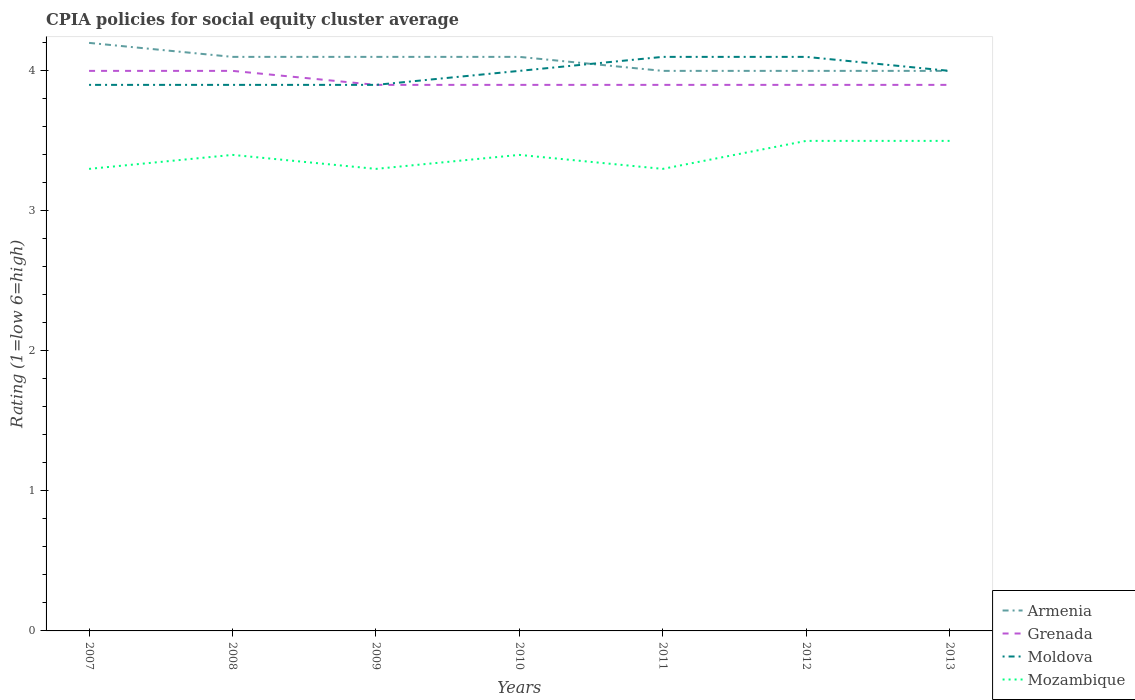How many different coloured lines are there?
Offer a very short reply. 4. Across all years, what is the maximum CPIA rating in Moldova?
Offer a very short reply. 3.9. In which year was the CPIA rating in Armenia maximum?
Offer a very short reply. 2011. What is the difference between the highest and the second highest CPIA rating in Mozambique?
Your response must be concise. 0.2. Is the CPIA rating in Mozambique strictly greater than the CPIA rating in Grenada over the years?
Your response must be concise. Yes. What is the title of the graph?
Your response must be concise. CPIA policies for social equity cluster average. What is the label or title of the X-axis?
Your response must be concise. Years. What is the label or title of the Y-axis?
Offer a terse response. Rating (1=low 6=high). What is the Rating (1=low 6=high) in Grenada in 2007?
Your answer should be compact. 4. What is the Rating (1=low 6=high) of Armenia in 2008?
Your answer should be compact. 4.1. What is the Rating (1=low 6=high) in Grenada in 2008?
Offer a terse response. 4. What is the Rating (1=low 6=high) in Mozambique in 2008?
Ensure brevity in your answer.  3.4. What is the Rating (1=low 6=high) in Armenia in 2009?
Make the answer very short. 4.1. What is the Rating (1=low 6=high) of Moldova in 2009?
Your answer should be very brief. 3.9. What is the Rating (1=low 6=high) in Mozambique in 2009?
Your response must be concise. 3.3. What is the Rating (1=low 6=high) of Armenia in 2010?
Ensure brevity in your answer.  4.1. What is the Rating (1=low 6=high) of Mozambique in 2010?
Offer a terse response. 3.4. What is the Rating (1=low 6=high) of Moldova in 2011?
Your answer should be compact. 4.1. What is the Rating (1=low 6=high) in Mozambique in 2011?
Your answer should be very brief. 3.3. What is the Rating (1=low 6=high) in Armenia in 2012?
Your response must be concise. 4. What is the Rating (1=low 6=high) of Mozambique in 2012?
Provide a succinct answer. 3.5. What is the Rating (1=low 6=high) of Armenia in 2013?
Make the answer very short. 4. What is the Rating (1=low 6=high) in Mozambique in 2013?
Offer a very short reply. 3.5. Across all years, what is the maximum Rating (1=low 6=high) of Grenada?
Provide a succinct answer. 4. Across all years, what is the maximum Rating (1=low 6=high) in Moldova?
Your answer should be very brief. 4.1. Across all years, what is the maximum Rating (1=low 6=high) of Mozambique?
Give a very brief answer. 3.5. Across all years, what is the minimum Rating (1=low 6=high) in Moldova?
Your answer should be compact. 3.9. What is the total Rating (1=low 6=high) of Armenia in the graph?
Your response must be concise. 28.5. What is the total Rating (1=low 6=high) of Grenada in the graph?
Offer a very short reply. 27.5. What is the total Rating (1=low 6=high) in Moldova in the graph?
Keep it short and to the point. 27.9. What is the total Rating (1=low 6=high) of Mozambique in the graph?
Your response must be concise. 23.7. What is the difference between the Rating (1=low 6=high) in Armenia in 2007 and that in 2008?
Your response must be concise. 0.1. What is the difference between the Rating (1=low 6=high) of Grenada in 2007 and that in 2008?
Ensure brevity in your answer.  0. What is the difference between the Rating (1=low 6=high) of Grenada in 2007 and that in 2009?
Keep it short and to the point. 0.1. What is the difference between the Rating (1=low 6=high) of Moldova in 2007 and that in 2009?
Provide a succinct answer. 0. What is the difference between the Rating (1=low 6=high) in Mozambique in 2007 and that in 2009?
Offer a very short reply. 0. What is the difference between the Rating (1=low 6=high) in Moldova in 2007 and that in 2010?
Your response must be concise. -0.1. What is the difference between the Rating (1=low 6=high) in Armenia in 2007 and that in 2011?
Give a very brief answer. 0.2. What is the difference between the Rating (1=low 6=high) in Moldova in 2007 and that in 2011?
Your response must be concise. -0.2. What is the difference between the Rating (1=low 6=high) in Mozambique in 2007 and that in 2011?
Offer a terse response. 0. What is the difference between the Rating (1=low 6=high) in Moldova in 2007 and that in 2012?
Give a very brief answer. -0.2. What is the difference between the Rating (1=low 6=high) of Mozambique in 2007 and that in 2012?
Provide a short and direct response. -0.2. What is the difference between the Rating (1=low 6=high) in Grenada in 2007 and that in 2013?
Ensure brevity in your answer.  0.1. What is the difference between the Rating (1=low 6=high) in Mozambique in 2007 and that in 2013?
Provide a succinct answer. -0.2. What is the difference between the Rating (1=low 6=high) of Mozambique in 2008 and that in 2009?
Your answer should be very brief. 0.1. What is the difference between the Rating (1=low 6=high) in Armenia in 2008 and that in 2010?
Offer a terse response. 0. What is the difference between the Rating (1=low 6=high) of Moldova in 2008 and that in 2010?
Your response must be concise. -0.1. What is the difference between the Rating (1=low 6=high) in Mozambique in 2008 and that in 2011?
Give a very brief answer. 0.1. What is the difference between the Rating (1=low 6=high) of Armenia in 2008 and that in 2012?
Make the answer very short. 0.1. What is the difference between the Rating (1=low 6=high) in Moldova in 2008 and that in 2012?
Your answer should be very brief. -0.2. What is the difference between the Rating (1=low 6=high) of Mozambique in 2008 and that in 2012?
Offer a very short reply. -0.1. What is the difference between the Rating (1=low 6=high) of Armenia in 2008 and that in 2013?
Make the answer very short. 0.1. What is the difference between the Rating (1=low 6=high) of Grenada in 2008 and that in 2013?
Provide a succinct answer. 0.1. What is the difference between the Rating (1=low 6=high) in Mozambique in 2008 and that in 2013?
Provide a succinct answer. -0.1. What is the difference between the Rating (1=low 6=high) in Mozambique in 2009 and that in 2010?
Provide a succinct answer. -0.1. What is the difference between the Rating (1=low 6=high) of Armenia in 2009 and that in 2011?
Offer a terse response. 0.1. What is the difference between the Rating (1=low 6=high) of Grenada in 2009 and that in 2011?
Give a very brief answer. 0. What is the difference between the Rating (1=low 6=high) of Moldova in 2009 and that in 2011?
Your response must be concise. -0.2. What is the difference between the Rating (1=low 6=high) in Armenia in 2009 and that in 2013?
Ensure brevity in your answer.  0.1. What is the difference between the Rating (1=low 6=high) of Grenada in 2009 and that in 2013?
Provide a short and direct response. 0. What is the difference between the Rating (1=low 6=high) in Moldova in 2009 and that in 2013?
Your answer should be compact. -0.1. What is the difference between the Rating (1=low 6=high) in Armenia in 2010 and that in 2011?
Keep it short and to the point. 0.1. What is the difference between the Rating (1=low 6=high) of Grenada in 2010 and that in 2011?
Keep it short and to the point. 0. What is the difference between the Rating (1=low 6=high) in Moldova in 2010 and that in 2011?
Give a very brief answer. -0.1. What is the difference between the Rating (1=low 6=high) of Mozambique in 2010 and that in 2011?
Give a very brief answer. 0.1. What is the difference between the Rating (1=low 6=high) in Armenia in 2010 and that in 2012?
Provide a short and direct response. 0.1. What is the difference between the Rating (1=low 6=high) of Grenada in 2010 and that in 2012?
Your answer should be compact. 0. What is the difference between the Rating (1=low 6=high) of Moldova in 2010 and that in 2012?
Provide a short and direct response. -0.1. What is the difference between the Rating (1=low 6=high) of Armenia in 2010 and that in 2013?
Provide a short and direct response. 0.1. What is the difference between the Rating (1=low 6=high) of Moldova in 2010 and that in 2013?
Offer a very short reply. 0. What is the difference between the Rating (1=low 6=high) in Mozambique in 2010 and that in 2013?
Your response must be concise. -0.1. What is the difference between the Rating (1=low 6=high) of Mozambique in 2011 and that in 2012?
Offer a very short reply. -0.2. What is the difference between the Rating (1=low 6=high) in Mozambique in 2011 and that in 2013?
Keep it short and to the point. -0.2. What is the difference between the Rating (1=low 6=high) in Armenia in 2012 and that in 2013?
Make the answer very short. 0. What is the difference between the Rating (1=low 6=high) in Grenada in 2012 and that in 2013?
Keep it short and to the point. 0. What is the difference between the Rating (1=low 6=high) of Mozambique in 2012 and that in 2013?
Give a very brief answer. 0. What is the difference between the Rating (1=low 6=high) of Armenia in 2007 and the Rating (1=low 6=high) of Grenada in 2008?
Provide a succinct answer. 0.2. What is the difference between the Rating (1=low 6=high) of Grenada in 2007 and the Rating (1=low 6=high) of Moldova in 2008?
Make the answer very short. 0.1. What is the difference between the Rating (1=low 6=high) of Grenada in 2007 and the Rating (1=low 6=high) of Mozambique in 2008?
Your answer should be very brief. 0.6. What is the difference between the Rating (1=low 6=high) of Armenia in 2007 and the Rating (1=low 6=high) of Grenada in 2009?
Provide a short and direct response. 0.3. What is the difference between the Rating (1=low 6=high) in Armenia in 2007 and the Rating (1=low 6=high) in Mozambique in 2009?
Provide a succinct answer. 0.9. What is the difference between the Rating (1=low 6=high) in Moldova in 2007 and the Rating (1=low 6=high) in Mozambique in 2009?
Your answer should be very brief. 0.6. What is the difference between the Rating (1=low 6=high) in Armenia in 2007 and the Rating (1=low 6=high) in Grenada in 2010?
Keep it short and to the point. 0.3. What is the difference between the Rating (1=low 6=high) of Grenada in 2007 and the Rating (1=low 6=high) of Moldova in 2010?
Offer a terse response. 0. What is the difference between the Rating (1=low 6=high) in Moldova in 2007 and the Rating (1=low 6=high) in Mozambique in 2010?
Offer a terse response. 0.5. What is the difference between the Rating (1=low 6=high) in Armenia in 2007 and the Rating (1=low 6=high) in Grenada in 2011?
Provide a short and direct response. 0.3. What is the difference between the Rating (1=low 6=high) of Armenia in 2007 and the Rating (1=low 6=high) of Moldova in 2011?
Make the answer very short. 0.1. What is the difference between the Rating (1=low 6=high) in Armenia in 2007 and the Rating (1=low 6=high) in Mozambique in 2011?
Keep it short and to the point. 0.9. What is the difference between the Rating (1=low 6=high) in Armenia in 2007 and the Rating (1=low 6=high) in Grenada in 2012?
Provide a short and direct response. 0.3. What is the difference between the Rating (1=low 6=high) in Armenia in 2007 and the Rating (1=low 6=high) in Mozambique in 2012?
Your answer should be compact. 0.7. What is the difference between the Rating (1=low 6=high) of Grenada in 2007 and the Rating (1=low 6=high) of Mozambique in 2012?
Your response must be concise. 0.5. What is the difference between the Rating (1=low 6=high) in Armenia in 2007 and the Rating (1=low 6=high) in Moldova in 2013?
Offer a very short reply. 0.2. What is the difference between the Rating (1=low 6=high) in Moldova in 2007 and the Rating (1=low 6=high) in Mozambique in 2013?
Keep it short and to the point. 0.4. What is the difference between the Rating (1=low 6=high) in Grenada in 2008 and the Rating (1=low 6=high) in Moldova in 2009?
Provide a short and direct response. 0.1. What is the difference between the Rating (1=low 6=high) of Armenia in 2008 and the Rating (1=low 6=high) of Grenada in 2010?
Your answer should be very brief. 0.2. What is the difference between the Rating (1=low 6=high) of Armenia in 2008 and the Rating (1=low 6=high) of Moldova in 2010?
Provide a short and direct response. 0.1. What is the difference between the Rating (1=low 6=high) of Armenia in 2008 and the Rating (1=low 6=high) of Mozambique in 2010?
Offer a very short reply. 0.7. What is the difference between the Rating (1=low 6=high) of Grenada in 2008 and the Rating (1=low 6=high) of Moldova in 2010?
Make the answer very short. 0. What is the difference between the Rating (1=low 6=high) of Armenia in 2008 and the Rating (1=low 6=high) of Moldova in 2011?
Provide a short and direct response. 0. What is the difference between the Rating (1=low 6=high) in Armenia in 2008 and the Rating (1=low 6=high) in Mozambique in 2011?
Your answer should be very brief. 0.8. What is the difference between the Rating (1=low 6=high) of Grenada in 2008 and the Rating (1=low 6=high) of Moldova in 2011?
Your answer should be very brief. -0.1. What is the difference between the Rating (1=low 6=high) in Grenada in 2008 and the Rating (1=low 6=high) in Mozambique in 2011?
Your answer should be compact. 0.7. What is the difference between the Rating (1=low 6=high) of Moldova in 2008 and the Rating (1=low 6=high) of Mozambique in 2011?
Your answer should be very brief. 0.6. What is the difference between the Rating (1=low 6=high) of Armenia in 2008 and the Rating (1=low 6=high) of Mozambique in 2012?
Give a very brief answer. 0.6. What is the difference between the Rating (1=low 6=high) in Grenada in 2008 and the Rating (1=low 6=high) in Mozambique in 2012?
Your answer should be compact. 0.5. What is the difference between the Rating (1=low 6=high) of Moldova in 2008 and the Rating (1=low 6=high) of Mozambique in 2012?
Your answer should be very brief. 0.4. What is the difference between the Rating (1=low 6=high) in Armenia in 2008 and the Rating (1=low 6=high) in Grenada in 2013?
Give a very brief answer. 0.2. What is the difference between the Rating (1=low 6=high) in Armenia in 2008 and the Rating (1=low 6=high) in Moldova in 2013?
Your answer should be very brief. 0.1. What is the difference between the Rating (1=low 6=high) of Armenia in 2008 and the Rating (1=low 6=high) of Mozambique in 2013?
Give a very brief answer. 0.6. What is the difference between the Rating (1=low 6=high) of Grenada in 2008 and the Rating (1=low 6=high) of Moldova in 2013?
Your answer should be compact. 0. What is the difference between the Rating (1=low 6=high) in Moldova in 2008 and the Rating (1=low 6=high) in Mozambique in 2013?
Offer a very short reply. 0.4. What is the difference between the Rating (1=low 6=high) of Armenia in 2009 and the Rating (1=low 6=high) of Grenada in 2010?
Provide a short and direct response. 0.2. What is the difference between the Rating (1=low 6=high) in Armenia in 2009 and the Rating (1=low 6=high) in Moldova in 2010?
Give a very brief answer. 0.1. What is the difference between the Rating (1=low 6=high) of Grenada in 2009 and the Rating (1=low 6=high) of Moldova in 2010?
Offer a very short reply. -0.1. What is the difference between the Rating (1=low 6=high) in Grenada in 2009 and the Rating (1=low 6=high) in Mozambique in 2010?
Provide a succinct answer. 0.5. What is the difference between the Rating (1=low 6=high) of Armenia in 2009 and the Rating (1=low 6=high) of Grenada in 2011?
Give a very brief answer. 0.2. What is the difference between the Rating (1=low 6=high) in Armenia in 2009 and the Rating (1=low 6=high) in Moldova in 2011?
Ensure brevity in your answer.  0. What is the difference between the Rating (1=low 6=high) of Grenada in 2009 and the Rating (1=low 6=high) of Moldova in 2011?
Provide a short and direct response. -0.2. What is the difference between the Rating (1=low 6=high) in Grenada in 2009 and the Rating (1=low 6=high) in Mozambique in 2011?
Make the answer very short. 0.6. What is the difference between the Rating (1=low 6=high) in Moldova in 2009 and the Rating (1=low 6=high) in Mozambique in 2011?
Make the answer very short. 0.6. What is the difference between the Rating (1=low 6=high) of Armenia in 2009 and the Rating (1=low 6=high) of Grenada in 2012?
Your answer should be compact. 0.2. What is the difference between the Rating (1=low 6=high) in Armenia in 2009 and the Rating (1=low 6=high) in Moldova in 2012?
Keep it short and to the point. 0. What is the difference between the Rating (1=low 6=high) of Grenada in 2009 and the Rating (1=low 6=high) of Moldova in 2012?
Your answer should be very brief. -0.2. What is the difference between the Rating (1=low 6=high) in Armenia in 2009 and the Rating (1=low 6=high) in Grenada in 2013?
Offer a very short reply. 0.2. What is the difference between the Rating (1=low 6=high) of Grenada in 2009 and the Rating (1=low 6=high) of Moldova in 2013?
Provide a succinct answer. -0.1. What is the difference between the Rating (1=low 6=high) in Armenia in 2010 and the Rating (1=low 6=high) in Moldova in 2011?
Offer a very short reply. 0. What is the difference between the Rating (1=low 6=high) in Armenia in 2010 and the Rating (1=low 6=high) in Mozambique in 2011?
Offer a very short reply. 0.8. What is the difference between the Rating (1=low 6=high) of Moldova in 2010 and the Rating (1=low 6=high) of Mozambique in 2011?
Ensure brevity in your answer.  0.7. What is the difference between the Rating (1=low 6=high) in Armenia in 2010 and the Rating (1=low 6=high) in Grenada in 2012?
Ensure brevity in your answer.  0.2. What is the difference between the Rating (1=low 6=high) of Armenia in 2010 and the Rating (1=low 6=high) of Moldova in 2012?
Keep it short and to the point. 0. What is the difference between the Rating (1=low 6=high) in Armenia in 2010 and the Rating (1=low 6=high) in Mozambique in 2012?
Give a very brief answer. 0.6. What is the difference between the Rating (1=low 6=high) in Grenada in 2010 and the Rating (1=low 6=high) in Mozambique in 2012?
Your response must be concise. 0.4. What is the difference between the Rating (1=low 6=high) of Moldova in 2010 and the Rating (1=low 6=high) of Mozambique in 2012?
Offer a very short reply. 0.5. What is the difference between the Rating (1=low 6=high) in Armenia in 2010 and the Rating (1=low 6=high) in Grenada in 2013?
Offer a very short reply. 0.2. What is the difference between the Rating (1=low 6=high) of Armenia in 2010 and the Rating (1=low 6=high) of Moldova in 2013?
Ensure brevity in your answer.  0.1. What is the difference between the Rating (1=low 6=high) in Grenada in 2010 and the Rating (1=low 6=high) in Moldova in 2013?
Provide a short and direct response. -0.1. What is the difference between the Rating (1=low 6=high) in Grenada in 2011 and the Rating (1=low 6=high) in Moldova in 2012?
Offer a terse response. -0.2. What is the difference between the Rating (1=low 6=high) of Grenada in 2011 and the Rating (1=low 6=high) of Mozambique in 2012?
Provide a succinct answer. 0.4. What is the difference between the Rating (1=low 6=high) of Armenia in 2011 and the Rating (1=low 6=high) of Moldova in 2013?
Provide a succinct answer. 0. What is the difference between the Rating (1=low 6=high) of Grenada in 2011 and the Rating (1=low 6=high) of Moldova in 2013?
Your response must be concise. -0.1. What is the difference between the Rating (1=low 6=high) in Armenia in 2012 and the Rating (1=low 6=high) in Grenada in 2013?
Keep it short and to the point. 0.1. What is the difference between the Rating (1=low 6=high) in Armenia in 2012 and the Rating (1=low 6=high) in Mozambique in 2013?
Offer a very short reply. 0.5. What is the difference between the Rating (1=low 6=high) in Grenada in 2012 and the Rating (1=low 6=high) in Moldova in 2013?
Offer a very short reply. -0.1. What is the difference between the Rating (1=low 6=high) in Grenada in 2012 and the Rating (1=low 6=high) in Mozambique in 2013?
Make the answer very short. 0.4. What is the difference between the Rating (1=low 6=high) in Moldova in 2012 and the Rating (1=low 6=high) in Mozambique in 2013?
Keep it short and to the point. 0.6. What is the average Rating (1=low 6=high) of Armenia per year?
Offer a terse response. 4.07. What is the average Rating (1=low 6=high) in Grenada per year?
Give a very brief answer. 3.93. What is the average Rating (1=low 6=high) in Moldova per year?
Your answer should be compact. 3.99. What is the average Rating (1=low 6=high) in Mozambique per year?
Offer a terse response. 3.39. In the year 2007, what is the difference between the Rating (1=low 6=high) in Armenia and Rating (1=low 6=high) in Moldova?
Your response must be concise. 0.3. In the year 2007, what is the difference between the Rating (1=low 6=high) of Armenia and Rating (1=low 6=high) of Mozambique?
Your answer should be compact. 0.9. In the year 2007, what is the difference between the Rating (1=low 6=high) of Grenada and Rating (1=low 6=high) of Moldova?
Offer a very short reply. 0.1. In the year 2007, what is the difference between the Rating (1=low 6=high) in Moldova and Rating (1=low 6=high) in Mozambique?
Make the answer very short. 0.6. In the year 2008, what is the difference between the Rating (1=low 6=high) of Armenia and Rating (1=low 6=high) of Moldova?
Your response must be concise. 0.2. In the year 2008, what is the difference between the Rating (1=low 6=high) of Armenia and Rating (1=low 6=high) of Mozambique?
Give a very brief answer. 0.7. In the year 2008, what is the difference between the Rating (1=low 6=high) in Grenada and Rating (1=low 6=high) in Moldova?
Provide a succinct answer. 0.1. In the year 2008, what is the difference between the Rating (1=low 6=high) of Grenada and Rating (1=low 6=high) of Mozambique?
Give a very brief answer. 0.6. In the year 2008, what is the difference between the Rating (1=low 6=high) of Moldova and Rating (1=low 6=high) of Mozambique?
Provide a short and direct response. 0.5. In the year 2010, what is the difference between the Rating (1=low 6=high) of Armenia and Rating (1=low 6=high) of Moldova?
Make the answer very short. 0.1. In the year 2010, what is the difference between the Rating (1=low 6=high) of Armenia and Rating (1=low 6=high) of Mozambique?
Offer a terse response. 0.7. In the year 2010, what is the difference between the Rating (1=low 6=high) of Grenada and Rating (1=low 6=high) of Moldova?
Your answer should be compact. -0.1. In the year 2011, what is the difference between the Rating (1=low 6=high) in Armenia and Rating (1=low 6=high) in Grenada?
Provide a short and direct response. 0.1. In the year 2011, what is the difference between the Rating (1=low 6=high) of Armenia and Rating (1=low 6=high) of Moldova?
Provide a succinct answer. -0.1. In the year 2011, what is the difference between the Rating (1=low 6=high) in Moldova and Rating (1=low 6=high) in Mozambique?
Give a very brief answer. 0.8. In the year 2012, what is the difference between the Rating (1=low 6=high) of Armenia and Rating (1=low 6=high) of Grenada?
Keep it short and to the point. 0.1. In the year 2012, what is the difference between the Rating (1=low 6=high) in Armenia and Rating (1=low 6=high) in Moldova?
Give a very brief answer. -0.1. In the year 2013, what is the difference between the Rating (1=low 6=high) of Armenia and Rating (1=low 6=high) of Moldova?
Ensure brevity in your answer.  0. In the year 2013, what is the difference between the Rating (1=low 6=high) of Grenada and Rating (1=low 6=high) of Moldova?
Your response must be concise. -0.1. What is the ratio of the Rating (1=low 6=high) in Armenia in 2007 to that in 2008?
Make the answer very short. 1.02. What is the ratio of the Rating (1=low 6=high) of Moldova in 2007 to that in 2008?
Give a very brief answer. 1. What is the ratio of the Rating (1=low 6=high) in Mozambique in 2007 to that in 2008?
Provide a short and direct response. 0.97. What is the ratio of the Rating (1=low 6=high) in Armenia in 2007 to that in 2009?
Make the answer very short. 1.02. What is the ratio of the Rating (1=low 6=high) in Grenada in 2007 to that in 2009?
Ensure brevity in your answer.  1.03. What is the ratio of the Rating (1=low 6=high) in Armenia in 2007 to that in 2010?
Make the answer very short. 1.02. What is the ratio of the Rating (1=low 6=high) in Grenada in 2007 to that in 2010?
Ensure brevity in your answer.  1.03. What is the ratio of the Rating (1=low 6=high) of Mozambique in 2007 to that in 2010?
Offer a terse response. 0.97. What is the ratio of the Rating (1=low 6=high) in Armenia in 2007 to that in 2011?
Provide a short and direct response. 1.05. What is the ratio of the Rating (1=low 6=high) of Grenada in 2007 to that in 2011?
Your response must be concise. 1.03. What is the ratio of the Rating (1=low 6=high) in Moldova in 2007 to that in 2011?
Provide a short and direct response. 0.95. What is the ratio of the Rating (1=low 6=high) of Grenada in 2007 to that in 2012?
Keep it short and to the point. 1.03. What is the ratio of the Rating (1=low 6=high) of Moldova in 2007 to that in 2012?
Ensure brevity in your answer.  0.95. What is the ratio of the Rating (1=low 6=high) in Mozambique in 2007 to that in 2012?
Ensure brevity in your answer.  0.94. What is the ratio of the Rating (1=low 6=high) in Grenada in 2007 to that in 2013?
Your answer should be compact. 1.03. What is the ratio of the Rating (1=low 6=high) in Mozambique in 2007 to that in 2013?
Offer a very short reply. 0.94. What is the ratio of the Rating (1=low 6=high) of Armenia in 2008 to that in 2009?
Your answer should be very brief. 1. What is the ratio of the Rating (1=low 6=high) in Grenada in 2008 to that in 2009?
Keep it short and to the point. 1.03. What is the ratio of the Rating (1=low 6=high) of Mozambique in 2008 to that in 2009?
Ensure brevity in your answer.  1.03. What is the ratio of the Rating (1=low 6=high) of Armenia in 2008 to that in 2010?
Ensure brevity in your answer.  1. What is the ratio of the Rating (1=low 6=high) of Grenada in 2008 to that in 2010?
Offer a terse response. 1.03. What is the ratio of the Rating (1=low 6=high) of Moldova in 2008 to that in 2010?
Your answer should be compact. 0.97. What is the ratio of the Rating (1=low 6=high) of Grenada in 2008 to that in 2011?
Make the answer very short. 1.03. What is the ratio of the Rating (1=low 6=high) in Moldova in 2008 to that in 2011?
Make the answer very short. 0.95. What is the ratio of the Rating (1=low 6=high) of Mozambique in 2008 to that in 2011?
Ensure brevity in your answer.  1.03. What is the ratio of the Rating (1=low 6=high) in Armenia in 2008 to that in 2012?
Give a very brief answer. 1.02. What is the ratio of the Rating (1=low 6=high) of Grenada in 2008 to that in 2012?
Your answer should be compact. 1.03. What is the ratio of the Rating (1=low 6=high) of Moldova in 2008 to that in 2012?
Your response must be concise. 0.95. What is the ratio of the Rating (1=low 6=high) in Mozambique in 2008 to that in 2012?
Offer a terse response. 0.97. What is the ratio of the Rating (1=low 6=high) of Grenada in 2008 to that in 2013?
Give a very brief answer. 1.03. What is the ratio of the Rating (1=low 6=high) of Moldova in 2008 to that in 2013?
Give a very brief answer. 0.97. What is the ratio of the Rating (1=low 6=high) of Mozambique in 2008 to that in 2013?
Ensure brevity in your answer.  0.97. What is the ratio of the Rating (1=low 6=high) in Armenia in 2009 to that in 2010?
Your response must be concise. 1. What is the ratio of the Rating (1=low 6=high) in Grenada in 2009 to that in 2010?
Provide a short and direct response. 1. What is the ratio of the Rating (1=low 6=high) in Moldova in 2009 to that in 2010?
Provide a short and direct response. 0.97. What is the ratio of the Rating (1=low 6=high) of Mozambique in 2009 to that in 2010?
Offer a terse response. 0.97. What is the ratio of the Rating (1=low 6=high) in Moldova in 2009 to that in 2011?
Provide a succinct answer. 0.95. What is the ratio of the Rating (1=low 6=high) in Mozambique in 2009 to that in 2011?
Your answer should be very brief. 1. What is the ratio of the Rating (1=low 6=high) in Grenada in 2009 to that in 2012?
Your answer should be compact. 1. What is the ratio of the Rating (1=low 6=high) of Moldova in 2009 to that in 2012?
Keep it short and to the point. 0.95. What is the ratio of the Rating (1=low 6=high) in Mozambique in 2009 to that in 2012?
Your response must be concise. 0.94. What is the ratio of the Rating (1=low 6=high) in Grenada in 2009 to that in 2013?
Make the answer very short. 1. What is the ratio of the Rating (1=low 6=high) in Moldova in 2009 to that in 2013?
Ensure brevity in your answer.  0.97. What is the ratio of the Rating (1=low 6=high) of Mozambique in 2009 to that in 2013?
Ensure brevity in your answer.  0.94. What is the ratio of the Rating (1=low 6=high) of Moldova in 2010 to that in 2011?
Make the answer very short. 0.98. What is the ratio of the Rating (1=low 6=high) in Mozambique in 2010 to that in 2011?
Your answer should be very brief. 1.03. What is the ratio of the Rating (1=low 6=high) of Armenia in 2010 to that in 2012?
Keep it short and to the point. 1.02. What is the ratio of the Rating (1=low 6=high) in Grenada in 2010 to that in 2012?
Offer a very short reply. 1. What is the ratio of the Rating (1=low 6=high) in Moldova in 2010 to that in 2012?
Give a very brief answer. 0.98. What is the ratio of the Rating (1=low 6=high) of Mozambique in 2010 to that in 2012?
Ensure brevity in your answer.  0.97. What is the ratio of the Rating (1=low 6=high) of Armenia in 2010 to that in 2013?
Offer a very short reply. 1.02. What is the ratio of the Rating (1=low 6=high) in Grenada in 2010 to that in 2013?
Ensure brevity in your answer.  1. What is the ratio of the Rating (1=low 6=high) in Mozambique in 2010 to that in 2013?
Keep it short and to the point. 0.97. What is the ratio of the Rating (1=low 6=high) in Mozambique in 2011 to that in 2012?
Provide a short and direct response. 0.94. What is the ratio of the Rating (1=low 6=high) of Armenia in 2011 to that in 2013?
Your response must be concise. 1. What is the ratio of the Rating (1=low 6=high) of Grenada in 2011 to that in 2013?
Offer a terse response. 1. What is the ratio of the Rating (1=low 6=high) of Mozambique in 2011 to that in 2013?
Give a very brief answer. 0.94. What is the ratio of the Rating (1=low 6=high) of Armenia in 2012 to that in 2013?
Offer a terse response. 1. What is the ratio of the Rating (1=low 6=high) of Moldova in 2012 to that in 2013?
Offer a very short reply. 1.02. What is the ratio of the Rating (1=low 6=high) of Mozambique in 2012 to that in 2013?
Keep it short and to the point. 1. What is the difference between the highest and the second highest Rating (1=low 6=high) of Armenia?
Make the answer very short. 0.1. What is the difference between the highest and the second highest Rating (1=low 6=high) of Grenada?
Make the answer very short. 0. What is the difference between the highest and the lowest Rating (1=low 6=high) in Armenia?
Ensure brevity in your answer.  0.2. What is the difference between the highest and the lowest Rating (1=low 6=high) of Mozambique?
Provide a succinct answer. 0.2. 